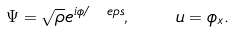<formula> <loc_0><loc_0><loc_500><loc_500>\Psi = \sqrt { \rho } e ^ { i \phi / \ e p s } , \quad u = \phi _ { x } .</formula> 